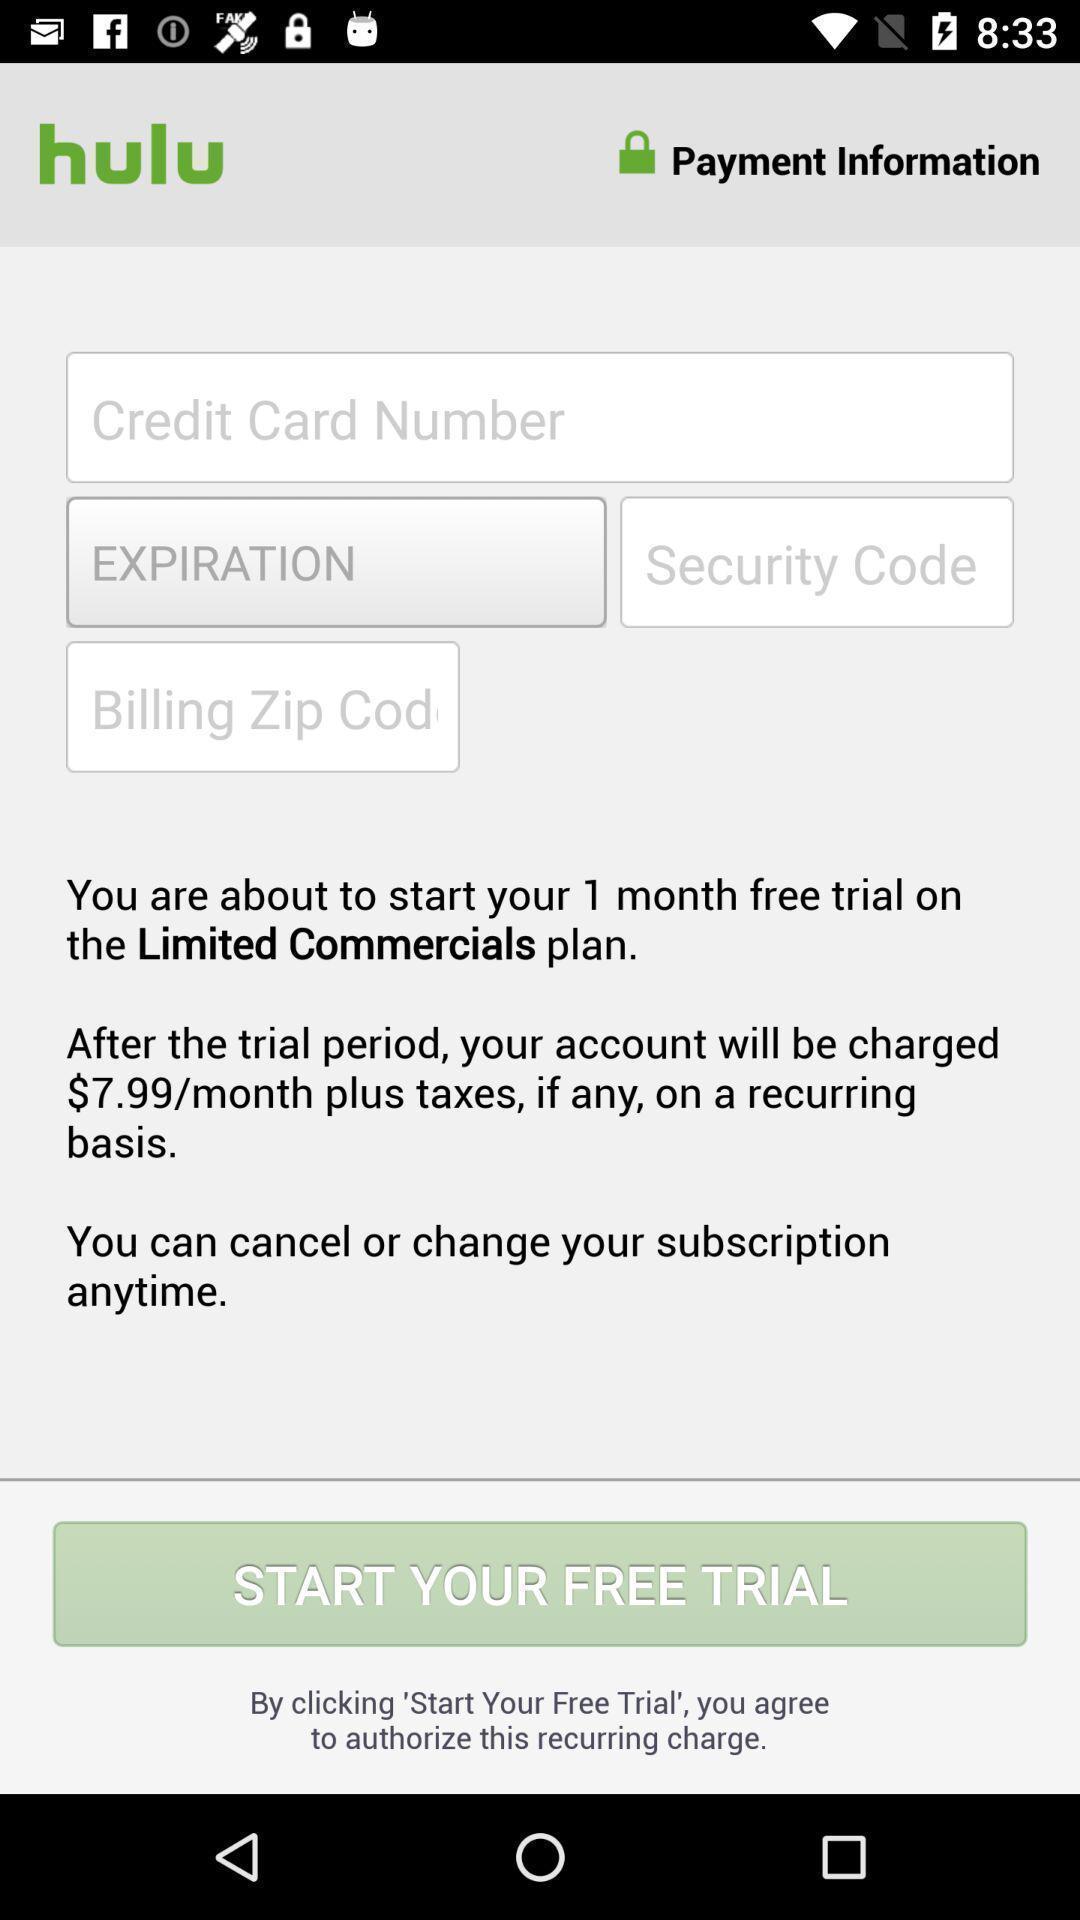Tell me what you see in this picture. Screen shows plan. 